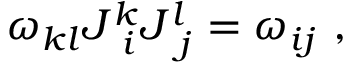<formula> <loc_0><loc_0><loc_500><loc_500>\omega _ { k l } J _ { \ i } ^ { k } J _ { \ j } ^ { l } = \omega _ { i j } \ ,</formula> 